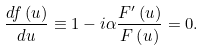<formula> <loc_0><loc_0><loc_500><loc_500>\frac { d f \left ( u \right ) } { d u } \equiv 1 - i \alpha \frac { F ^ { \prime } \left ( u \right ) } { F \left ( u \right ) } = 0 .</formula> 